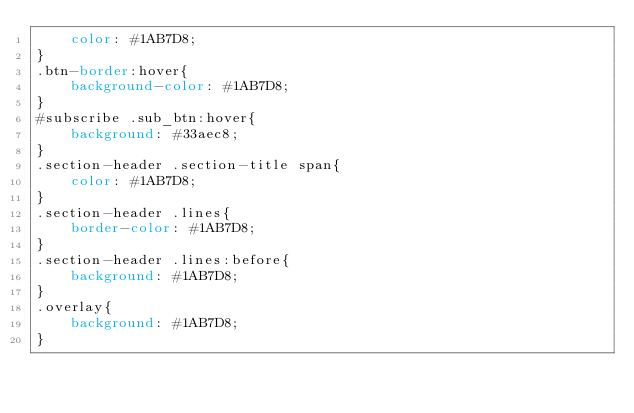Convert code to text. <code><loc_0><loc_0><loc_500><loc_500><_CSS_>    color: #1AB7D8;
}
.btn-border:hover{
	background-color: #1AB7D8;
}
#subscribe .sub_btn:hover{
	background: #33aec8;
}
.section-header .section-title span{
	color: #1AB7D8;
}
.section-header .lines{
	border-color: #1AB7D8; 
}
.section-header .lines:before{
	background: #1AB7D8;
}
.overlay{
	background: #1AB7D8;
}</code> 